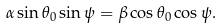Convert formula to latex. <formula><loc_0><loc_0><loc_500><loc_500>\alpha \sin \theta _ { 0 } \sin \psi = \beta \cos \theta _ { 0 } \cos \psi .</formula> 